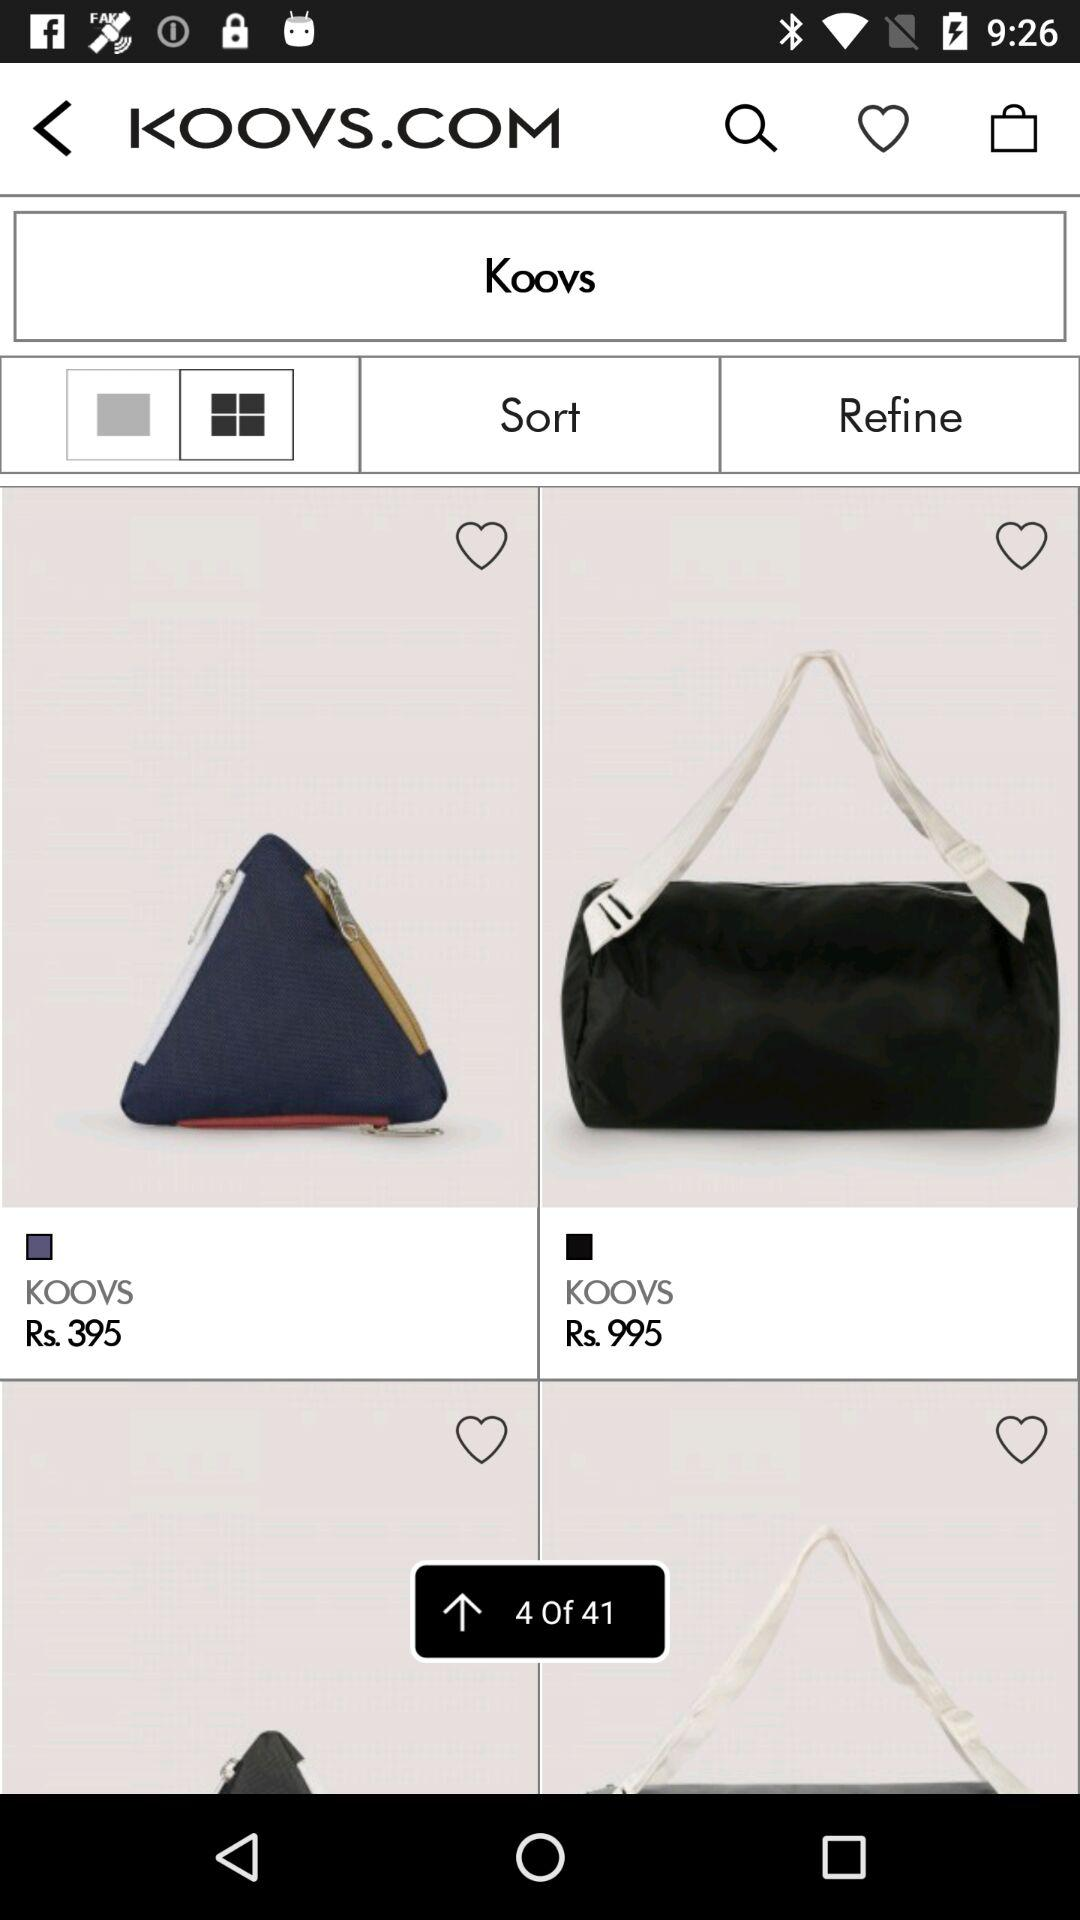How many items in total are there? There are 41 items in total. 